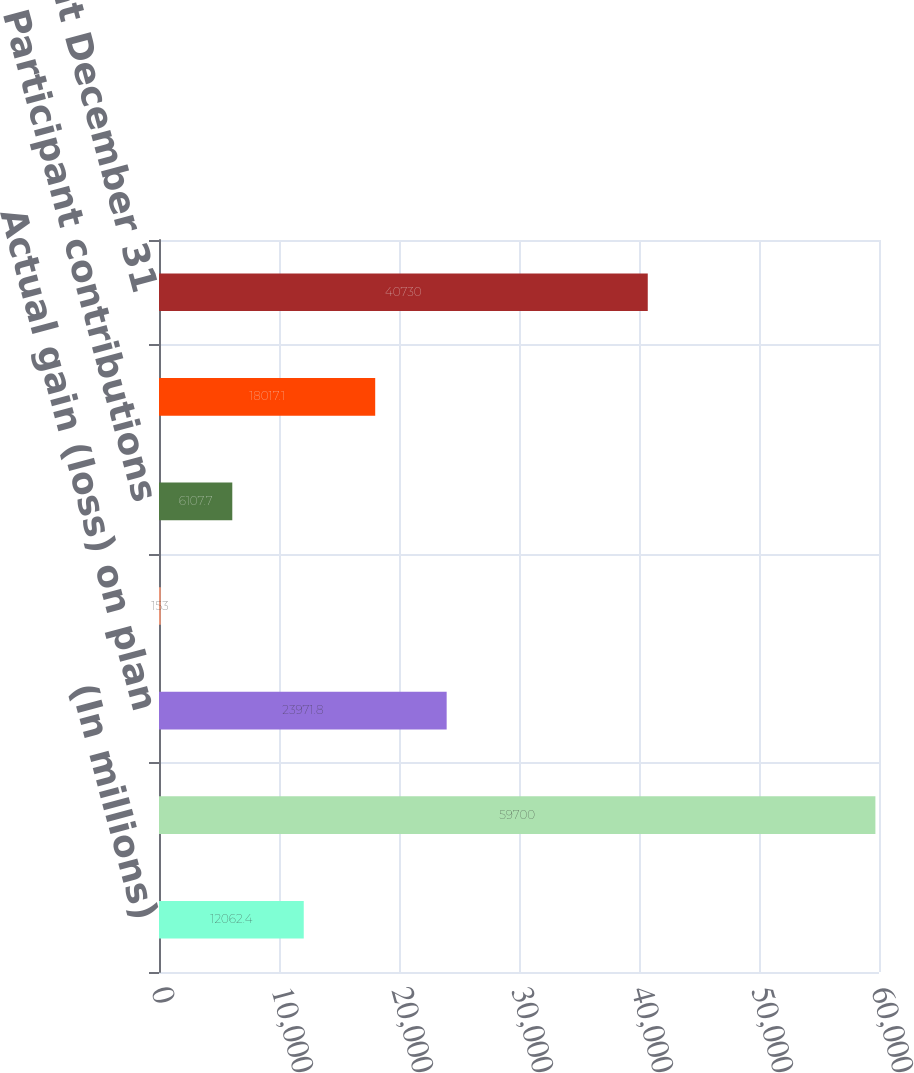Convert chart to OTSL. <chart><loc_0><loc_0><loc_500><loc_500><bar_chart><fcel>(In millions)<fcel>Balance at January 1<fcel>Actual gain (loss) on plan<fcel>Employer contributions<fcel>Participant contributions<fcel>Benefits paid<fcel>Balance at December 31<nl><fcel>12062.4<fcel>59700<fcel>23971.8<fcel>153<fcel>6107.7<fcel>18017.1<fcel>40730<nl></chart> 